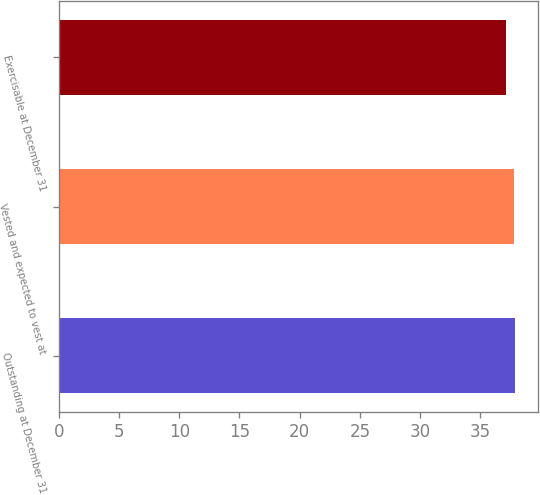Convert chart. <chart><loc_0><loc_0><loc_500><loc_500><bar_chart><fcel>Outstanding at December 31<fcel>Vested and expected to vest at<fcel>Exercisable at December 31<nl><fcel>37.88<fcel>37.77<fcel>37.16<nl></chart> 